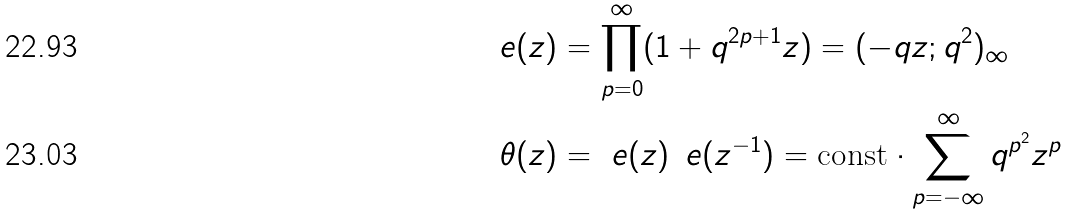Convert formula to latex. <formula><loc_0><loc_0><loc_500><loc_500>\ e ( z ) & = \prod _ { p = 0 } ^ { \infty } ( 1 + q ^ { 2 p + 1 } z ) = ( - q z ; q ^ { 2 } ) _ { \infty } \\ \theta ( z ) & = \ e ( z ) \, \ e ( z ^ { - 1 } ) = \text {const} \cdot \sum _ { p = - \infty } ^ { \infty } q ^ { p ^ { 2 } } z ^ { p }</formula> 